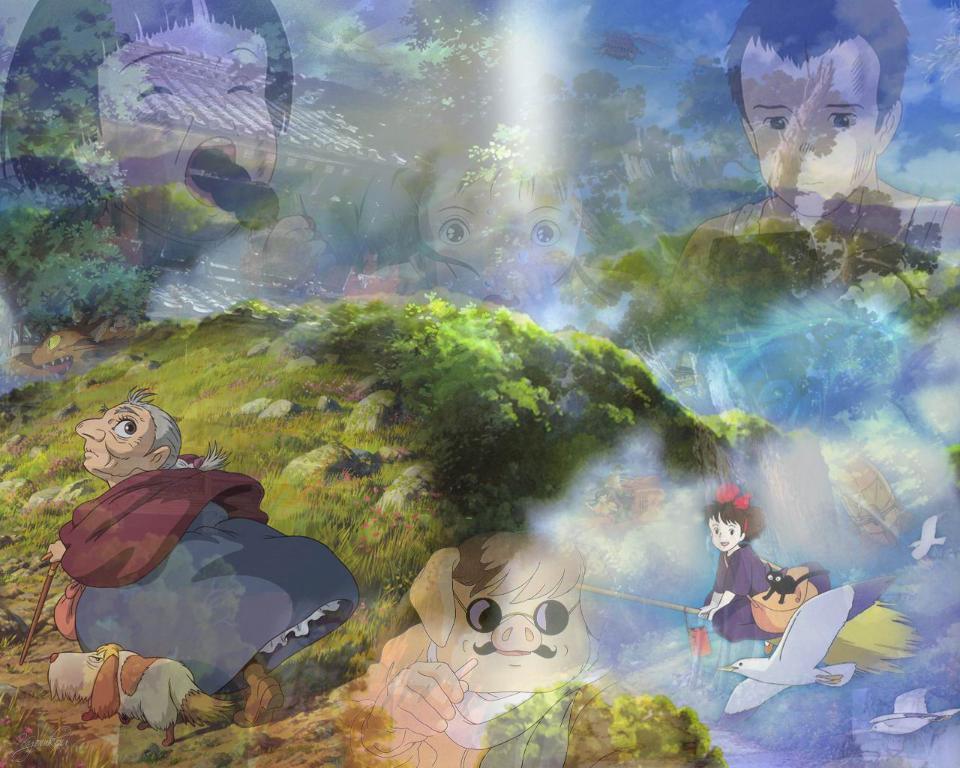Can you describe this image briefly? This is a cartoon image where I can see people, animals, birds, the sky, the grass, trees, houses and some other things. 